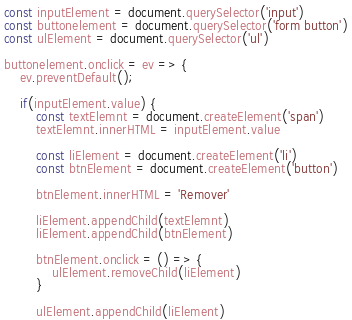<code> <loc_0><loc_0><loc_500><loc_500><_JavaScript_>const inputElement = document.querySelector('input')
const buttonelement = document.querySelector('form button')
const ulElement = document.querySelector('ul')

buttonelement.onclick = ev => {
    ev.preventDefault();

    if(inputElement.value) {
        const textElemnt = document.createElement('span')
        textElemnt.innerHTML = inputElement.value

        const liElement = document.createElement('li')
        const btnElement = document.createElement('button')

        btnElement.innerHTML = 'Remover'

        liElement.appendChild(textElemnt)
        liElement.appendChild(btnElement)

        btnElement.onclick = () => {
            ulElement.removeChild(liElement)
        }

        ulElement.appendChild(liElement)</code> 